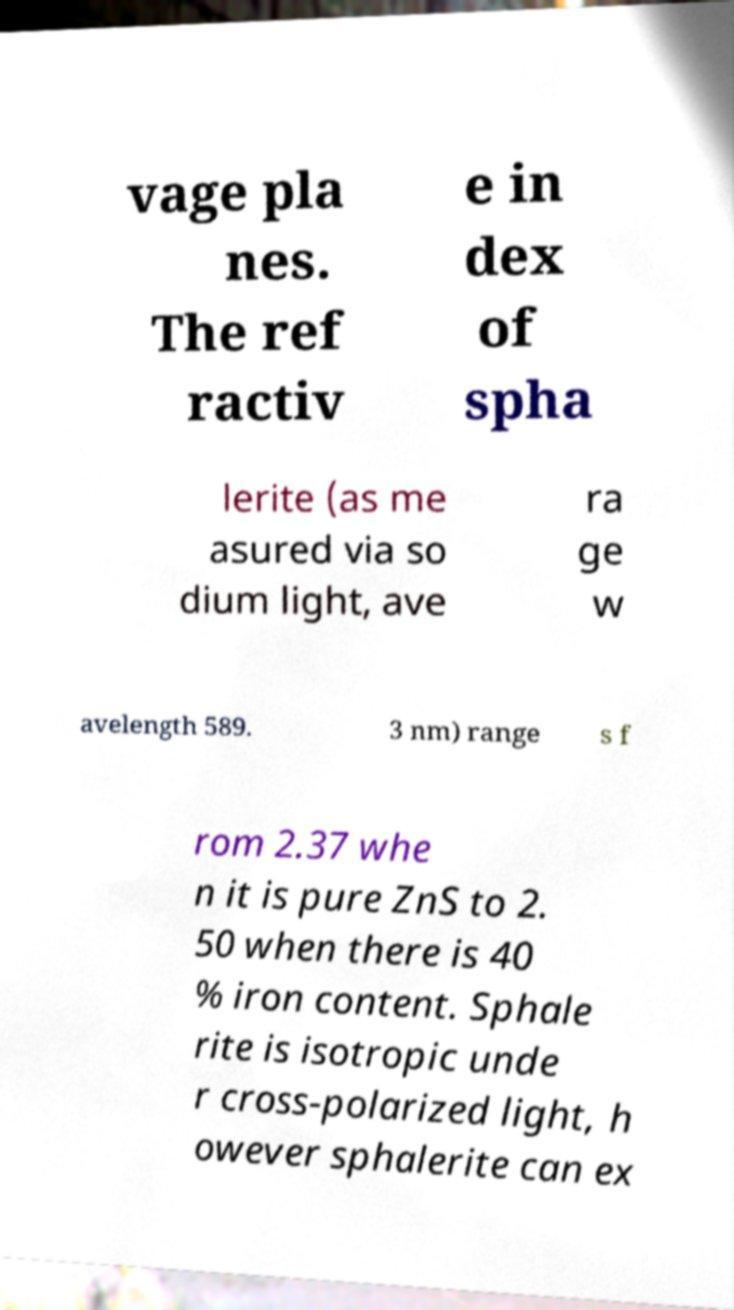Could you extract and type out the text from this image? vage pla nes. The ref ractiv e in dex of spha lerite (as me asured via so dium light, ave ra ge w avelength 589. 3 nm) range s f rom 2.37 whe n it is pure ZnS to 2. 50 when there is 40 % iron content. Sphale rite is isotropic unde r cross-polarized light, h owever sphalerite can ex 